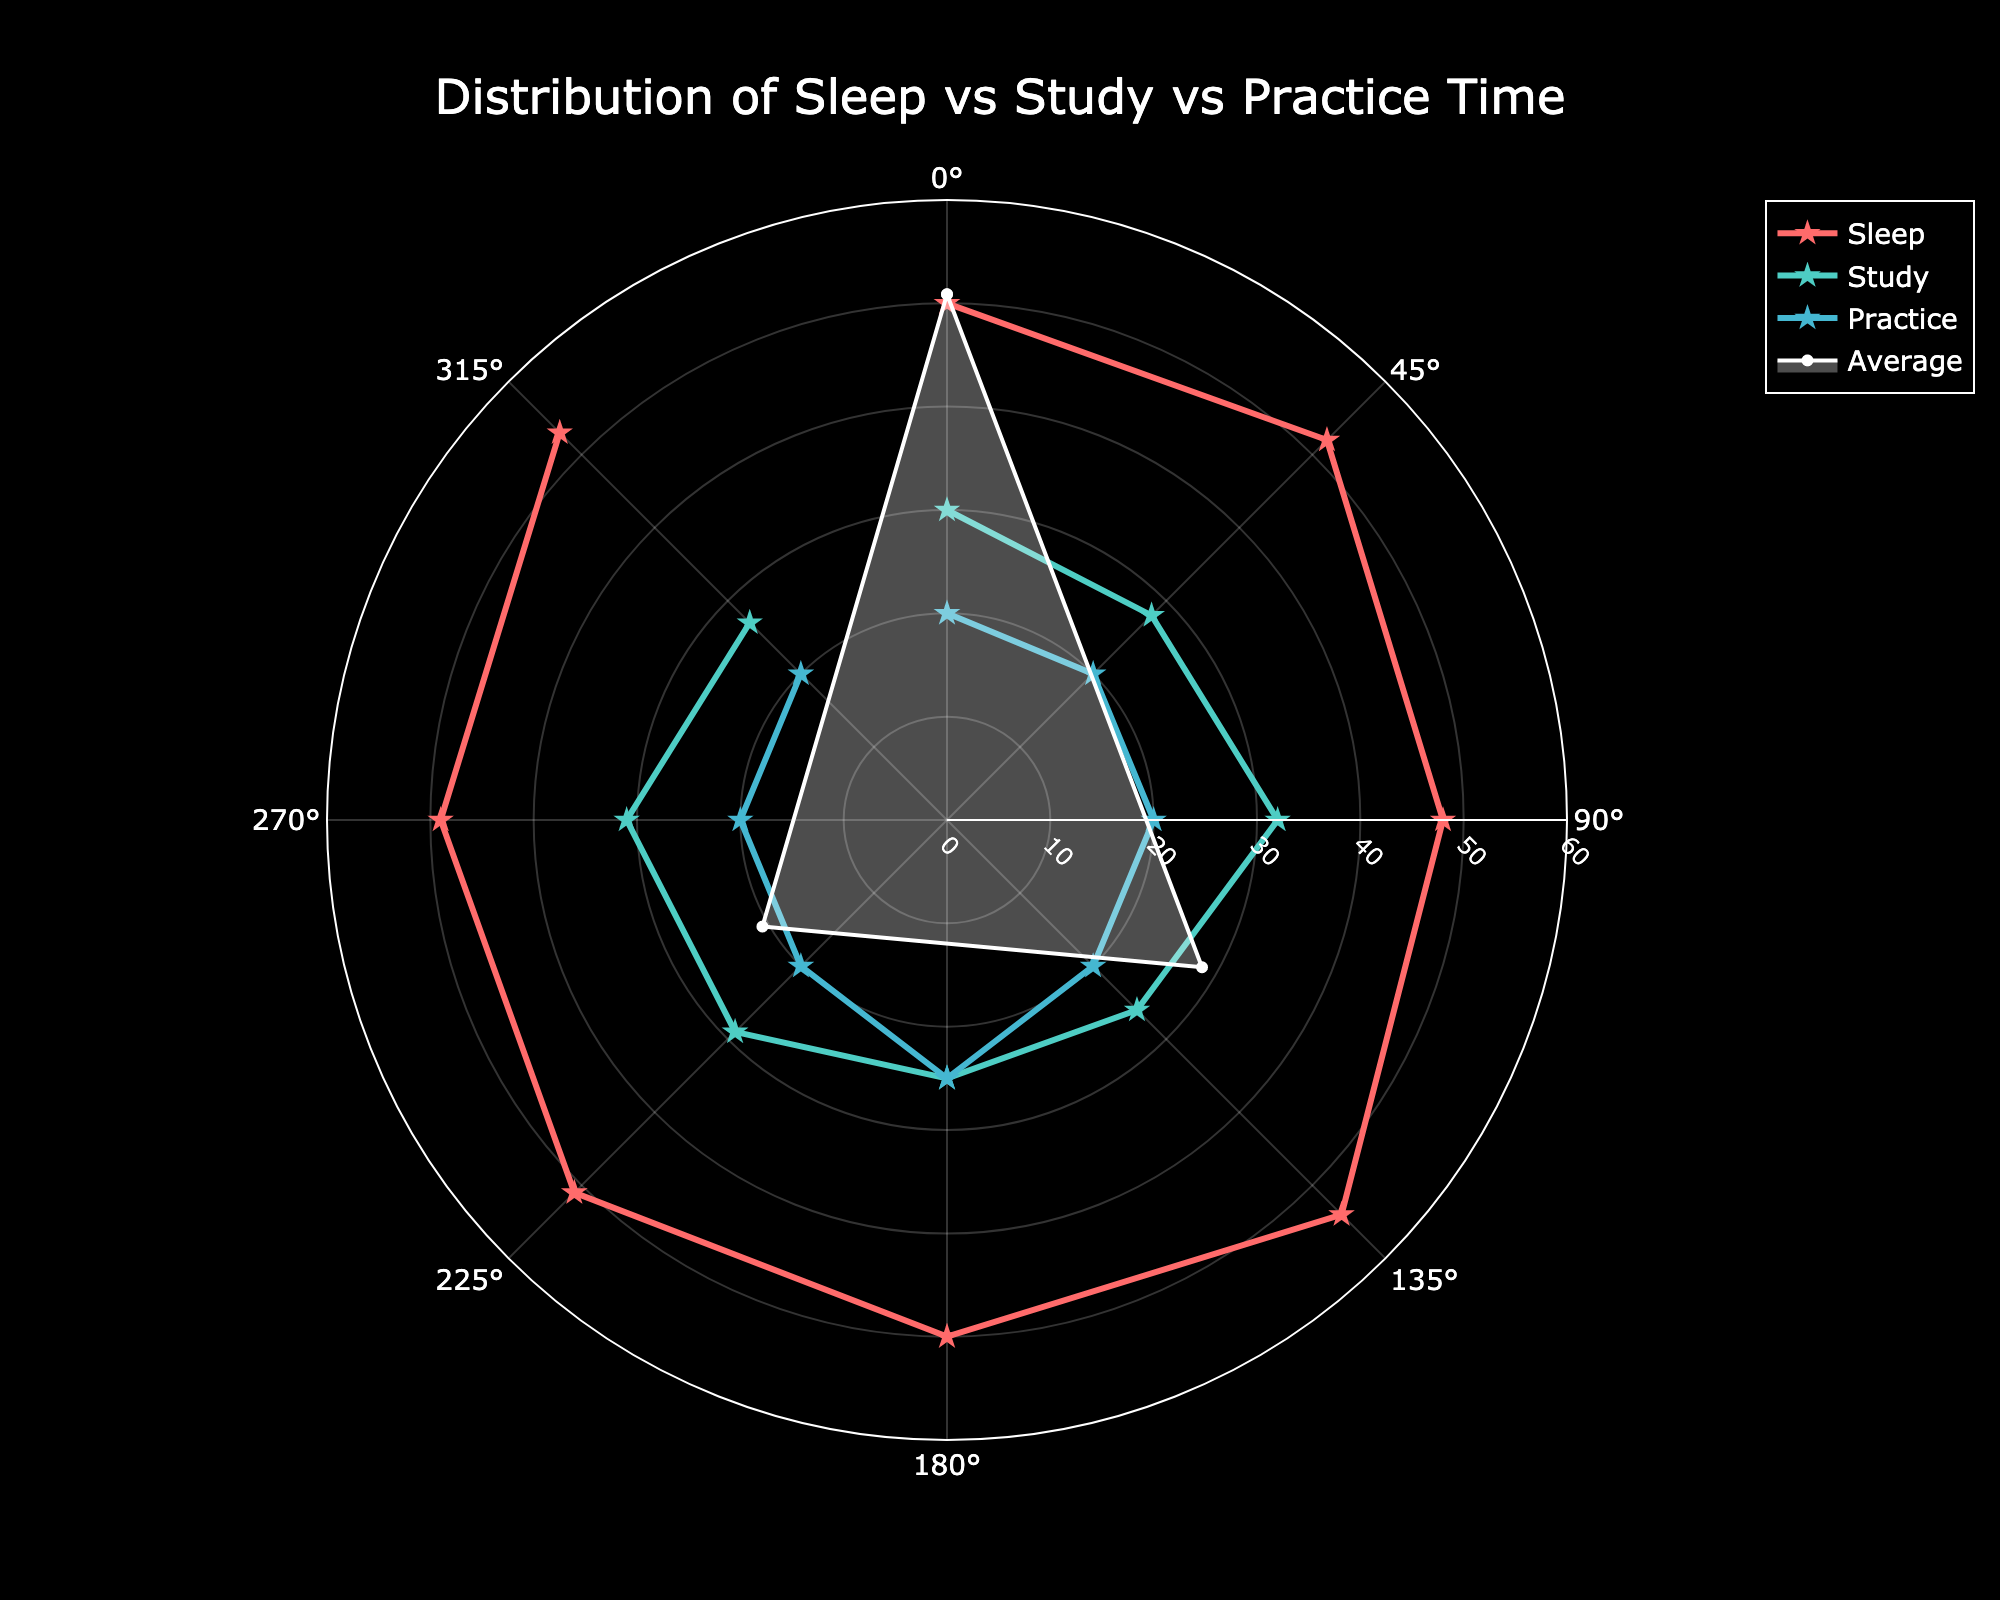What is the title of the figure? The title is visibly placed at the top of the chart and is a descriptive label summarizing the plot's focus.
Answer: Distribution of Sleep vs Study vs Practice Time How many data categories are represented in the chart? The chart's legend or the number of different colored lines in the plot indicates the distinct categories represented.
Answer: 3 (Sleep, Study, Practice) What color is used to represent the 'Sleep' category? By looking at the legend and matching it to the colors of the lines on the plot, you can identify the color coding.
Answer: Red (#FF6B6B) Which category has the highest average value? The filled area within the polar chart represents the averages for each category, comparing their heights reveals the highest average.
Answer: Sleep How many data points fall within the 'Study' time category? Observing the legend and identifying the 'Study' category color allows you to count the number of data points or symbols along the Study line.
Answer: 8 What are the average values of Sleep, Study, and Practice? The filled area within the chart indicates the average values, where you can read off the heights for each category.
Answer: Sleep: 51, Study: 28.5, Practice: 20 How does the average 'Study' time compare to the average 'Practice' time? Refer to the filled area representing average values, and compare the heights of 'Study' and 'Practice' categories.
Answer: Study time is higher What is the range of the radial axis? The radial axis’s labeled ticks show the range from the center to the outer edge.
Answer: 0 to 60 Does any student spend exactly 54 hours on sleep? The student data points for the 'Sleep' category line should be checked to see if any marker aligns with 54 hours.
Answer: Yes If you wanted to balance each category to an equal time, what would each category's time be? Sum the total average time across all categories and divide by the number of categories to find the balanced time for each.
Answer: (51+28.5+20)/3 = 33.17 Which category shows the most consistency around its average? Observe the spread of data points around the average line for each category and identify the one with the least variance.
Answer: Practice 